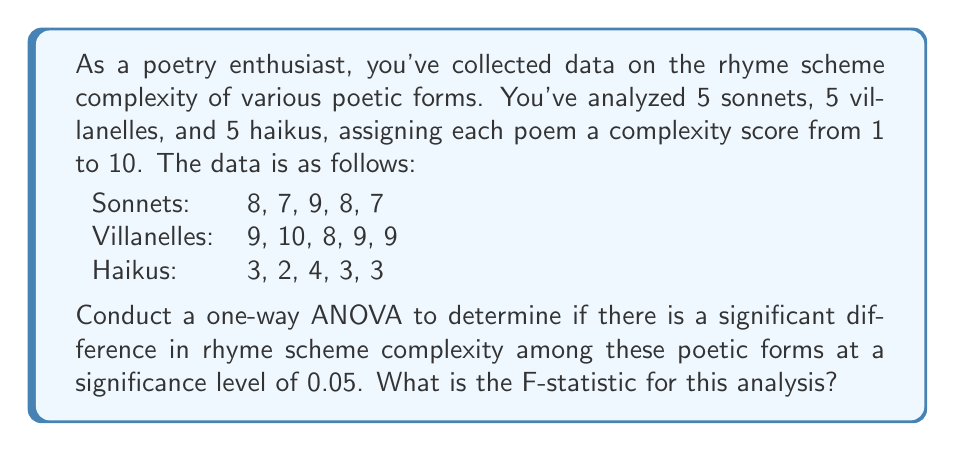Could you help me with this problem? To conduct a one-way ANOVA, we'll follow these steps:

1. Calculate the sum of squares between groups (SSB)
2. Calculate the sum of squares within groups (SSW)
3. Calculate the degrees of freedom (df)
4. Compute the mean square between groups (MSB) and mean square within groups (MSW)
5. Calculate the F-statistic

Step 1: Calculate SSB

First, we need to find the grand mean and group means:

Grand mean: $\bar{X} = \frac{(8+7+9+8+7+9+10+8+9+9+3+2+4+3+3)}{15} = 6.6$

Group means:
Sonnets: $\bar{X}_1 = 7.8$
Villanelles: $\bar{X}_2 = 9$
Haikus: $\bar{X}_3 = 3$

Now, we can calculate SSB:

$$SSB = \sum_{i=1}^k n_i(\bar{X}_i - \bar{X})^2$$

Where $k$ is the number of groups and $n_i$ is the number of observations in each group.

$$SSB = 5(7.8 - 6.6)^2 + 5(9 - 6.6)^2 + 5(3 - 6.6)^2 = 110.7$$

Step 2: Calculate SSW

$$SSW = \sum_{i=1}^k \sum_{j=1}^{n_i} (X_{ij} - \bar{X}_i)^2$$

Sonnets: $(8-7.8)^2 + (7-7.8)^2 + (9-7.8)^2 + (8-7.8)^2 + (7-7.8)^2 = 3.2$
Villanelles: $(9-9)^2 + (10-9)^2 + (8-9)^2 + (9-9)^2 + (9-9)^2 = 2$
Haikus: $(3-3)^2 + (2-3)^2 + (4-3)^2 + (3-3)^2 + (3-3)^2 = 2$

$$SSW = 3.2 + 2 + 2 = 7.2$$

Step 3: Calculate degrees of freedom

dfB (between groups) = k - 1 = 3 - 1 = 2
dfW (within groups) = N - k = 15 - 3 = 12
Where N is the total number of observations

Step 4: Compute MSB and MSW

$$MSB = \frac{SSB}{dfB} = \frac{110.7}{2} = 55.35$$
$$MSW = \frac{SSW}{dfW} = \frac{7.2}{12} = 0.6$$

Step 5: Calculate the F-statistic

$$F = \frac{MSB}{MSW} = \frac{55.35}{0.6} = 92.25$$
Answer: The F-statistic for this one-way ANOVA is 92.25. 